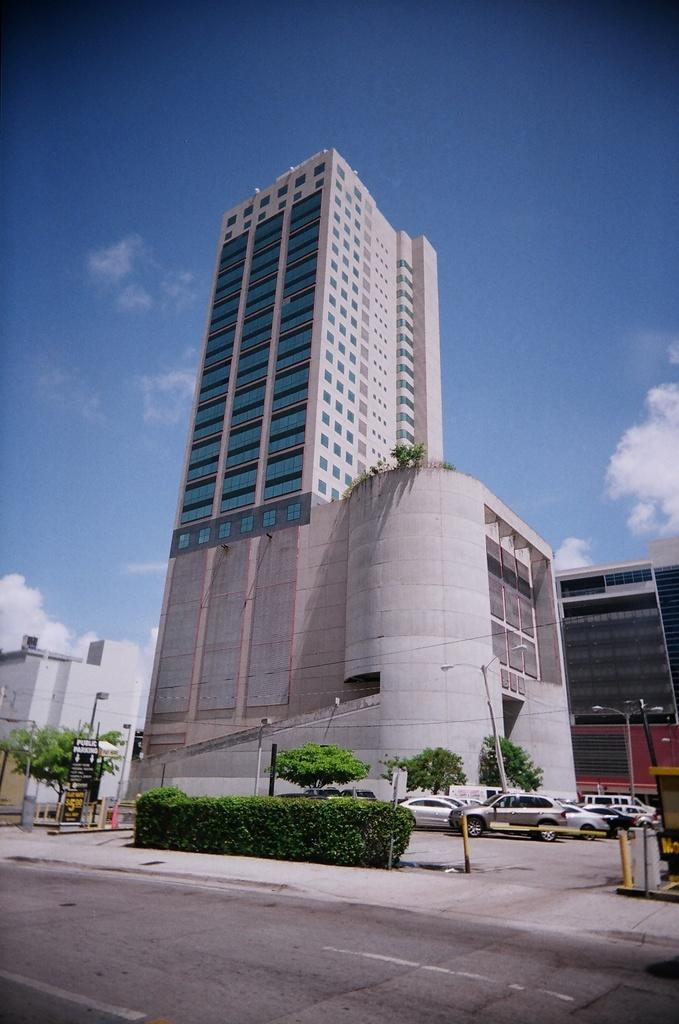What can be seen on the road at the bottom of the image? There are vehicles on the road at the bottom of the image. What type of natural elements are present in the image? There are plants and trees in the image. What man-made structures can be seen in the image? There are poles, hoardings, and buildings in the image. What architectural feature can be seen in the background of the image? There are glass doors in the background of the image. What is visible in the sky in the background of the image? There are clouds in the sky in the background of the image. What type of war is being depicted in the image? There is no depiction of war in the image; it features vehicles on the road, plants, trees, poles, hoardings, buildings, glass doors, and clouds in the sky. Where is the dock located in the image? There is no dock present in the image. 